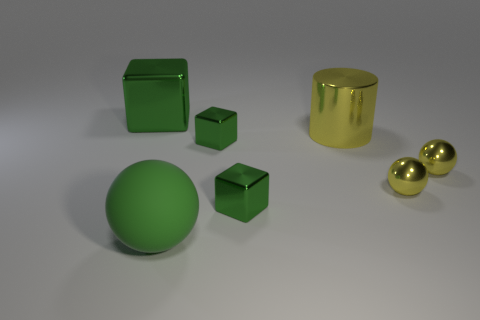Subtract all green cubes. How many were subtracted if there are1green cubes left? 2 Subtract all tiny metal blocks. How many blocks are left? 1 Subtract 1 balls. How many balls are left? 2 Add 1 green spheres. How many objects exist? 8 Subtract 0 purple balls. How many objects are left? 7 Subtract all cylinders. How many objects are left? 6 Subtract all small shiny objects. Subtract all big things. How many objects are left? 0 Add 1 tiny yellow things. How many tiny yellow things are left? 3 Add 6 tiny blue rubber cylinders. How many tiny blue rubber cylinders exist? 6 